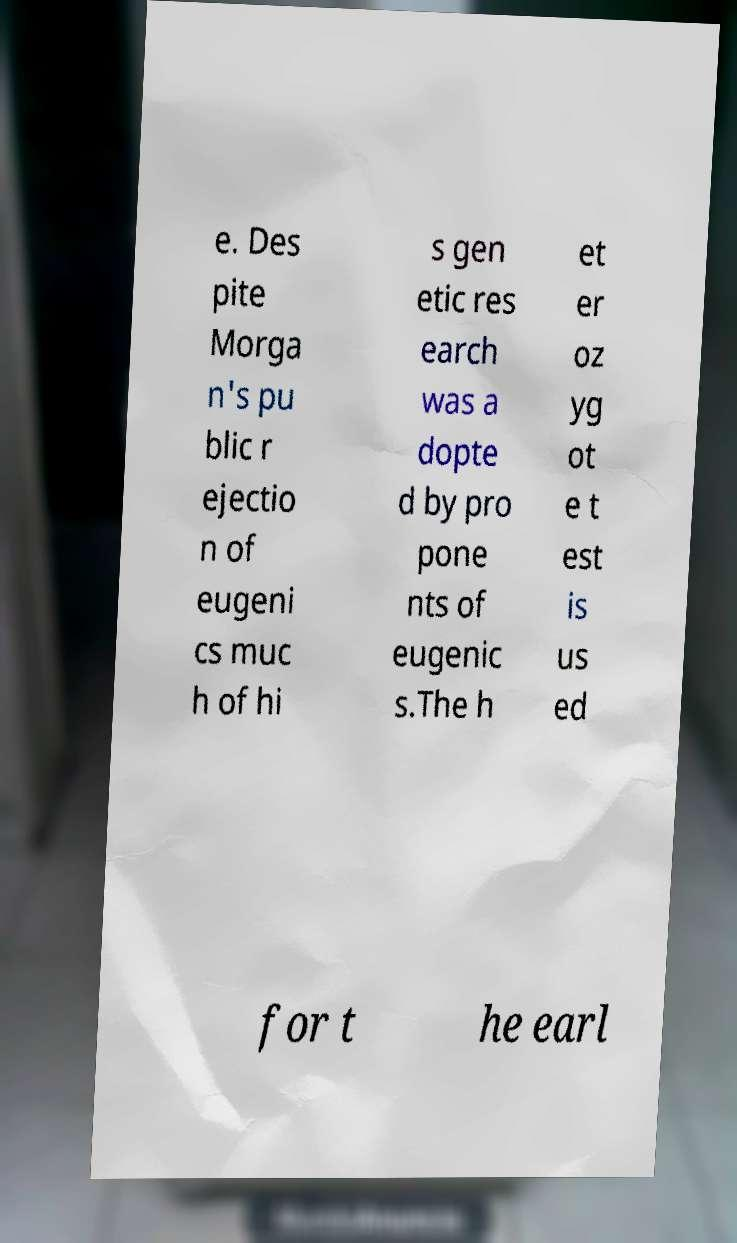Please identify and transcribe the text found in this image. e. Des pite Morga n's pu blic r ejectio n of eugeni cs muc h of hi s gen etic res earch was a dopte d by pro pone nts of eugenic s.The h et er oz yg ot e t est is us ed for t he earl 